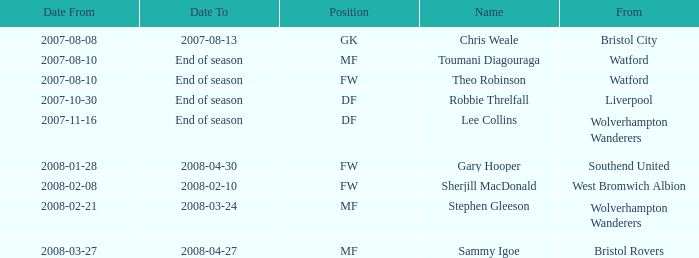What was the from for the Date From of 2007-08-08? Bristol City. Could you parse the entire table as a dict? {'header': ['Date From', 'Date To', 'Position', 'Name', 'From'], 'rows': [['2007-08-08', '2007-08-13', 'GK', 'Chris Weale', 'Bristol City'], ['2007-08-10', 'End of season', 'MF', 'Toumani Diagouraga', 'Watford'], ['2007-08-10', 'End of season', 'FW', 'Theo Robinson', 'Watford'], ['2007-10-30', 'End of season', 'DF', 'Robbie Threlfall', 'Liverpool'], ['2007-11-16', 'End of season', 'DF', 'Lee Collins', 'Wolverhampton Wanderers'], ['2008-01-28', '2008-04-30', 'FW', 'Gary Hooper', 'Southend United'], ['2008-02-08', '2008-02-10', 'FW', 'Sherjill MacDonald', 'West Bromwich Albion'], ['2008-02-21', '2008-03-24', 'MF', 'Stephen Gleeson', 'Wolverhampton Wanderers'], ['2008-03-27', '2008-04-27', 'MF', 'Sammy Igoe', 'Bristol Rovers']]} 